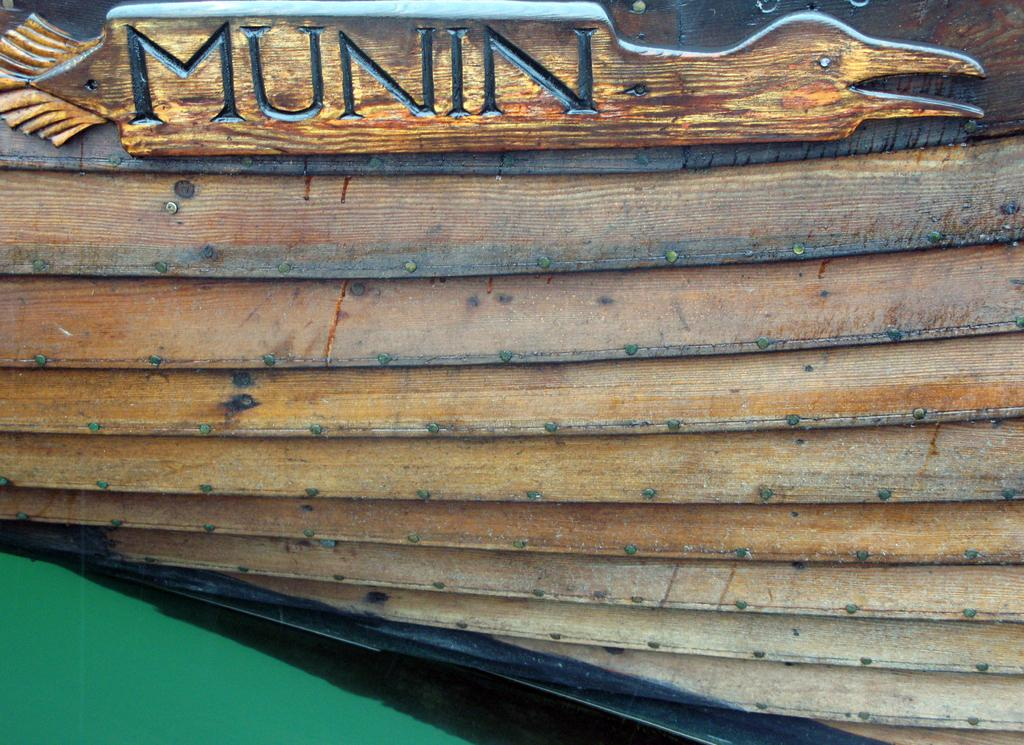What material is the main subject of the image made of? There is wood in the center of the image. What is done to the wood in the image? There is carving on the wood. What can be seen in the bottom left corner of the image? There is a green area in the bottom left corner of the image. How many pencils are being used to draw the carving on the wood in the image? There is no indication in the image that pencils are being used to draw the carving on the wood. 